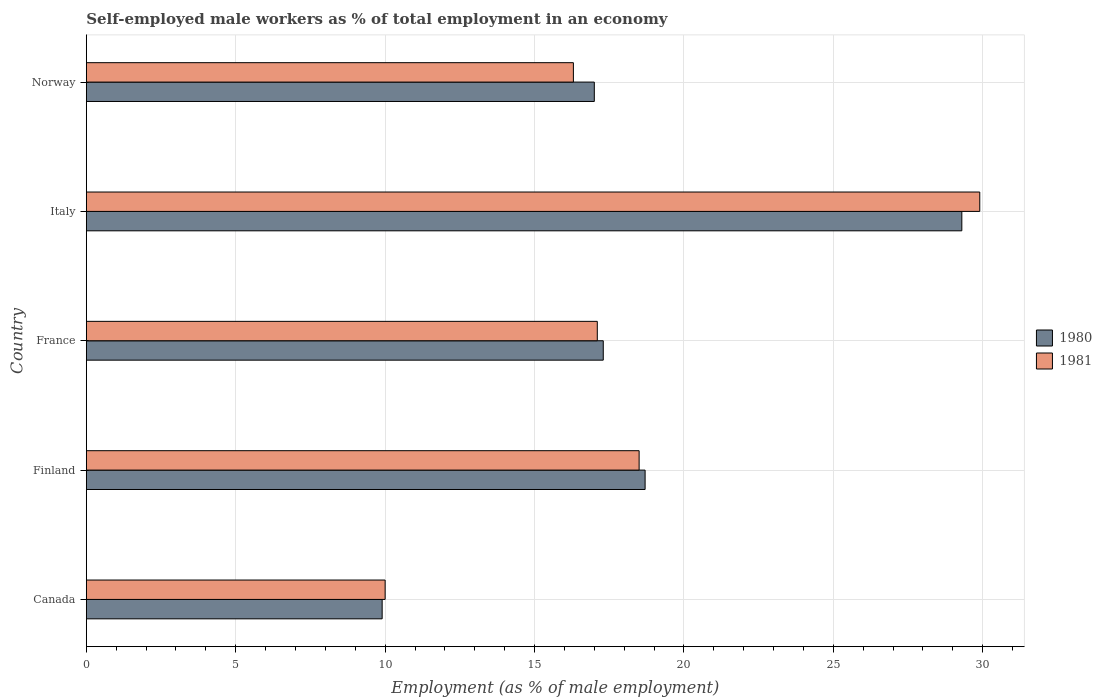How many groups of bars are there?
Make the answer very short. 5. Are the number of bars on each tick of the Y-axis equal?
Your response must be concise. Yes. How many bars are there on the 3rd tick from the bottom?
Give a very brief answer. 2. What is the label of the 5th group of bars from the top?
Your answer should be very brief. Canada. In how many cases, is the number of bars for a given country not equal to the number of legend labels?
Ensure brevity in your answer.  0. What is the percentage of self-employed male workers in 1980 in Canada?
Give a very brief answer. 9.9. Across all countries, what is the maximum percentage of self-employed male workers in 1980?
Your response must be concise. 29.3. Across all countries, what is the minimum percentage of self-employed male workers in 1981?
Keep it short and to the point. 10. What is the total percentage of self-employed male workers in 1981 in the graph?
Your answer should be very brief. 91.8. What is the difference between the percentage of self-employed male workers in 1980 in Finland and that in France?
Keep it short and to the point. 1.4. What is the difference between the percentage of self-employed male workers in 1980 in Norway and the percentage of self-employed male workers in 1981 in France?
Offer a very short reply. -0.1. What is the average percentage of self-employed male workers in 1980 per country?
Give a very brief answer. 18.44. What is the difference between the percentage of self-employed male workers in 1980 and percentage of self-employed male workers in 1981 in Italy?
Make the answer very short. -0.6. In how many countries, is the percentage of self-employed male workers in 1981 greater than 5 %?
Provide a succinct answer. 5. What is the ratio of the percentage of self-employed male workers in 1980 in Finland to that in Norway?
Your answer should be compact. 1.1. Is the difference between the percentage of self-employed male workers in 1980 in Canada and Finland greater than the difference between the percentage of self-employed male workers in 1981 in Canada and Finland?
Offer a terse response. No. What is the difference between the highest and the second highest percentage of self-employed male workers in 1980?
Your response must be concise. 10.6. What is the difference between the highest and the lowest percentage of self-employed male workers in 1981?
Keep it short and to the point. 19.9. In how many countries, is the percentage of self-employed male workers in 1981 greater than the average percentage of self-employed male workers in 1981 taken over all countries?
Make the answer very short. 2. Is the sum of the percentage of self-employed male workers in 1981 in France and Norway greater than the maximum percentage of self-employed male workers in 1980 across all countries?
Your answer should be compact. Yes. What does the 1st bar from the top in France represents?
Provide a short and direct response. 1981. Are all the bars in the graph horizontal?
Provide a succinct answer. Yes. Are the values on the major ticks of X-axis written in scientific E-notation?
Provide a succinct answer. No. Where does the legend appear in the graph?
Offer a very short reply. Center right. How many legend labels are there?
Give a very brief answer. 2. What is the title of the graph?
Keep it short and to the point. Self-employed male workers as % of total employment in an economy. Does "1994" appear as one of the legend labels in the graph?
Your answer should be very brief. No. What is the label or title of the X-axis?
Give a very brief answer. Employment (as % of male employment). What is the label or title of the Y-axis?
Your answer should be very brief. Country. What is the Employment (as % of male employment) of 1980 in Canada?
Make the answer very short. 9.9. What is the Employment (as % of male employment) of 1981 in Canada?
Your response must be concise. 10. What is the Employment (as % of male employment) of 1980 in Finland?
Your answer should be compact. 18.7. What is the Employment (as % of male employment) in 1980 in France?
Keep it short and to the point. 17.3. What is the Employment (as % of male employment) in 1981 in France?
Keep it short and to the point. 17.1. What is the Employment (as % of male employment) of 1980 in Italy?
Your answer should be compact. 29.3. What is the Employment (as % of male employment) in 1981 in Italy?
Provide a short and direct response. 29.9. What is the Employment (as % of male employment) of 1980 in Norway?
Give a very brief answer. 17. What is the Employment (as % of male employment) of 1981 in Norway?
Ensure brevity in your answer.  16.3. Across all countries, what is the maximum Employment (as % of male employment) in 1980?
Ensure brevity in your answer.  29.3. Across all countries, what is the maximum Employment (as % of male employment) in 1981?
Make the answer very short. 29.9. Across all countries, what is the minimum Employment (as % of male employment) of 1980?
Your answer should be compact. 9.9. What is the total Employment (as % of male employment) of 1980 in the graph?
Offer a terse response. 92.2. What is the total Employment (as % of male employment) of 1981 in the graph?
Your answer should be compact. 91.8. What is the difference between the Employment (as % of male employment) of 1980 in Canada and that in Finland?
Your answer should be compact. -8.8. What is the difference between the Employment (as % of male employment) of 1980 in Canada and that in France?
Offer a very short reply. -7.4. What is the difference between the Employment (as % of male employment) in 1980 in Canada and that in Italy?
Offer a very short reply. -19.4. What is the difference between the Employment (as % of male employment) in 1981 in Canada and that in Italy?
Your response must be concise. -19.9. What is the difference between the Employment (as % of male employment) in 1980 in Canada and that in Norway?
Offer a terse response. -7.1. What is the difference between the Employment (as % of male employment) of 1980 in Finland and that in Norway?
Your answer should be compact. 1.7. What is the difference between the Employment (as % of male employment) of 1981 in Finland and that in Norway?
Give a very brief answer. 2.2. What is the difference between the Employment (as % of male employment) of 1980 in France and that in Italy?
Provide a short and direct response. -12. What is the difference between the Employment (as % of male employment) in 1981 in France and that in Italy?
Provide a short and direct response. -12.8. What is the difference between the Employment (as % of male employment) of 1980 in Canada and the Employment (as % of male employment) of 1981 in Norway?
Your answer should be compact. -6.4. What is the difference between the Employment (as % of male employment) of 1980 in Italy and the Employment (as % of male employment) of 1981 in Norway?
Your response must be concise. 13. What is the average Employment (as % of male employment) in 1980 per country?
Offer a very short reply. 18.44. What is the average Employment (as % of male employment) of 1981 per country?
Your response must be concise. 18.36. What is the difference between the Employment (as % of male employment) of 1980 and Employment (as % of male employment) of 1981 in Canada?
Your answer should be very brief. -0.1. What is the difference between the Employment (as % of male employment) of 1980 and Employment (as % of male employment) of 1981 in Finland?
Offer a very short reply. 0.2. What is the difference between the Employment (as % of male employment) of 1980 and Employment (as % of male employment) of 1981 in France?
Provide a succinct answer. 0.2. What is the ratio of the Employment (as % of male employment) of 1980 in Canada to that in Finland?
Give a very brief answer. 0.53. What is the ratio of the Employment (as % of male employment) of 1981 in Canada to that in Finland?
Provide a short and direct response. 0.54. What is the ratio of the Employment (as % of male employment) in 1980 in Canada to that in France?
Your answer should be very brief. 0.57. What is the ratio of the Employment (as % of male employment) in 1981 in Canada to that in France?
Give a very brief answer. 0.58. What is the ratio of the Employment (as % of male employment) of 1980 in Canada to that in Italy?
Your answer should be very brief. 0.34. What is the ratio of the Employment (as % of male employment) in 1981 in Canada to that in Italy?
Provide a short and direct response. 0.33. What is the ratio of the Employment (as % of male employment) in 1980 in Canada to that in Norway?
Make the answer very short. 0.58. What is the ratio of the Employment (as % of male employment) in 1981 in Canada to that in Norway?
Give a very brief answer. 0.61. What is the ratio of the Employment (as % of male employment) in 1980 in Finland to that in France?
Ensure brevity in your answer.  1.08. What is the ratio of the Employment (as % of male employment) in 1981 in Finland to that in France?
Keep it short and to the point. 1.08. What is the ratio of the Employment (as % of male employment) of 1980 in Finland to that in Italy?
Make the answer very short. 0.64. What is the ratio of the Employment (as % of male employment) in 1981 in Finland to that in Italy?
Your answer should be compact. 0.62. What is the ratio of the Employment (as % of male employment) of 1981 in Finland to that in Norway?
Offer a terse response. 1.14. What is the ratio of the Employment (as % of male employment) of 1980 in France to that in Italy?
Give a very brief answer. 0.59. What is the ratio of the Employment (as % of male employment) of 1981 in France to that in Italy?
Give a very brief answer. 0.57. What is the ratio of the Employment (as % of male employment) in 1980 in France to that in Norway?
Provide a short and direct response. 1.02. What is the ratio of the Employment (as % of male employment) of 1981 in France to that in Norway?
Make the answer very short. 1.05. What is the ratio of the Employment (as % of male employment) in 1980 in Italy to that in Norway?
Provide a succinct answer. 1.72. What is the ratio of the Employment (as % of male employment) of 1981 in Italy to that in Norway?
Ensure brevity in your answer.  1.83. What is the difference between the highest and the lowest Employment (as % of male employment) of 1980?
Provide a succinct answer. 19.4. What is the difference between the highest and the lowest Employment (as % of male employment) of 1981?
Ensure brevity in your answer.  19.9. 